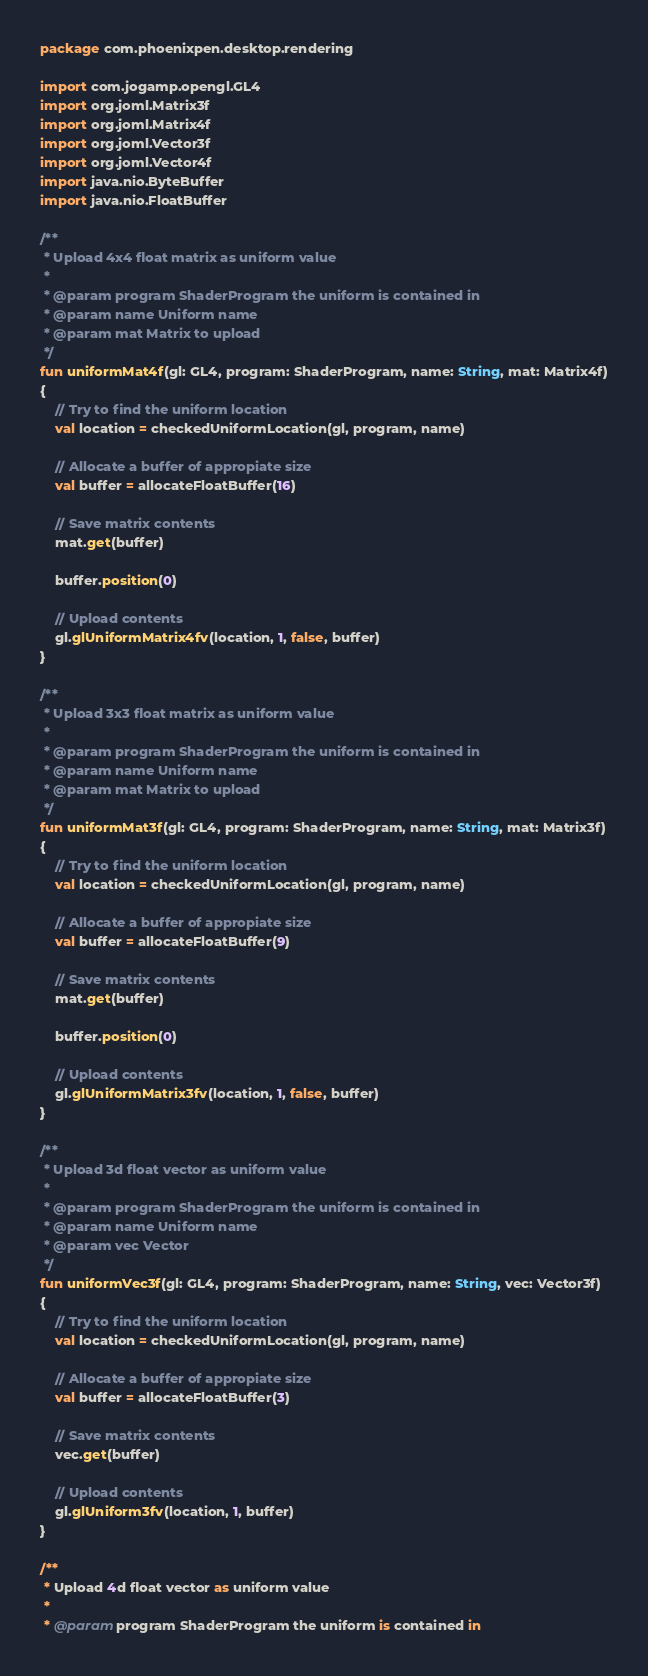<code> <loc_0><loc_0><loc_500><loc_500><_Kotlin_>package com.phoenixpen.desktop.rendering

import com.jogamp.opengl.GL4
import org.joml.Matrix3f
import org.joml.Matrix4f
import org.joml.Vector3f
import org.joml.Vector4f
import java.nio.ByteBuffer
import java.nio.FloatBuffer

/**
 * Upload 4x4 float matrix as uniform value
 *
 * @param program ShaderProgram the uniform is contained in
 * @param name Uniform name
 * @param mat Matrix to upload
 */
fun uniformMat4f(gl: GL4, program: ShaderProgram, name: String, mat: Matrix4f)
{
    // Try to find the uniform location
    val location = checkedUniformLocation(gl, program, name)

    // Allocate a buffer of appropiate size
    val buffer = allocateFloatBuffer(16)

    // Save matrix contents
    mat.get(buffer)

    buffer.position(0)

    // Upload contents
    gl.glUniformMatrix4fv(location, 1, false, buffer)
}

/**
 * Upload 3x3 float matrix as uniform value
 *
 * @param program ShaderProgram the uniform is contained in
 * @param name Uniform name
 * @param mat Matrix to upload
 */
fun uniformMat3f(gl: GL4, program: ShaderProgram, name: String, mat: Matrix3f)
{
    // Try to find the uniform location
    val location = checkedUniformLocation(gl, program, name)

    // Allocate a buffer of appropiate size
    val buffer = allocateFloatBuffer(9)

    // Save matrix contents
    mat.get(buffer)

    buffer.position(0)

    // Upload contents
    gl.glUniformMatrix3fv(location, 1, false, buffer)
}

/**
 * Upload 3d float vector as uniform value
 *
 * @param program ShaderProgram the uniform is contained in
 * @param name Uniform name
 * @param vec Vector
 */
fun uniformVec3f(gl: GL4, program: ShaderProgram, name: String, vec: Vector3f)
{
    // Try to find the uniform location
    val location = checkedUniformLocation(gl, program, name)

    // Allocate a buffer of appropiate size
    val buffer = allocateFloatBuffer(3)

    // Save matrix contents
    vec.get(buffer)

    // Upload contents
    gl.glUniform3fv(location, 1, buffer)
}

/**
 * Upload 4d float vector as uniform value
 *
 * @param program ShaderProgram the uniform is contained in</code> 